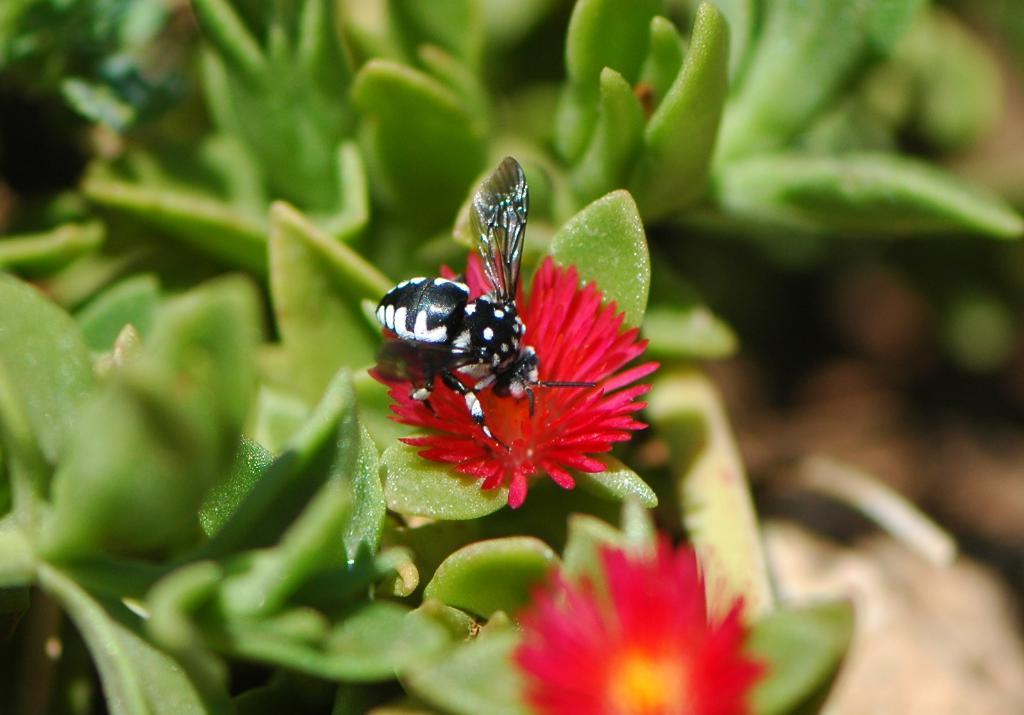What type of flowers can be seen in the image? There are red color flowers in the image. Are there any other living organisms present on the flowers? Yes, an insect is present on one of the flowers. What can be seen in the background of the image? There are green leaves in the background of the image. How are the leaves depicted in the image? The leaves are blurred in the image. What type of cheese is being used to decorate the cake in the image? There is no cake or cheese present in the image; it features red color flowers, an insect, and green leaves. 